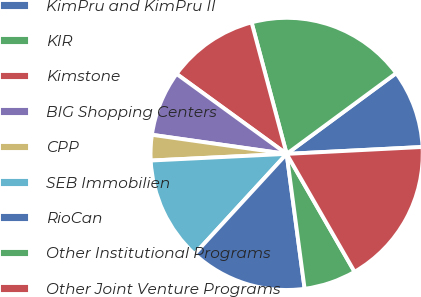Convert chart to OTSL. <chart><loc_0><loc_0><loc_500><loc_500><pie_chart><fcel>KimPru and KimPru II<fcel>KIR<fcel>Kimstone<fcel>BIG Shopping Centers<fcel>CPP<fcel>SEB Immobilien<fcel>RioCan<fcel>Other Institutional Programs<fcel>Other Joint Venture Programs<nl><fcel>9.3%<fcel>19.04%<fcel>10.85%<fcel>7.76%<fcel>3.02%<fcel>12.39%<fcel>13.94%<fcel>6.21%<fcel>17.49%<nl></chart> 